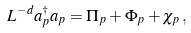<formula> <loc_0><loc_0><loc_500><loc_500>L ^ { - d } a _ { p } ^ { \dag } a _ { p } = \Pi _ { p } + \Phi _ { p } + \chi _ { p } \, ,</formula> 